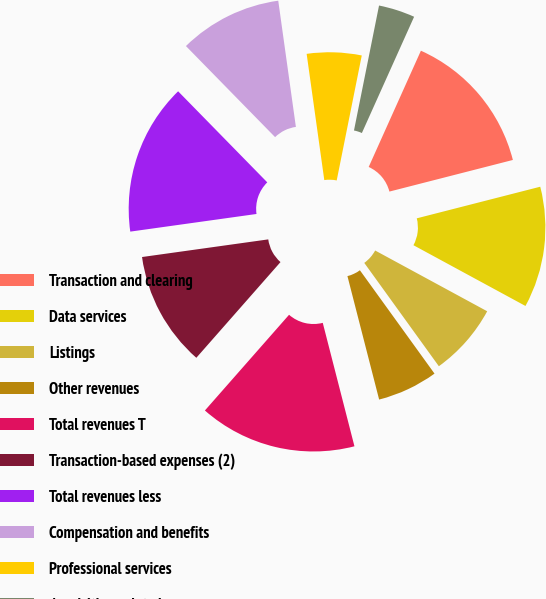Convert chart to OTSL. <chart><loc_0><loc_0><loc_500><loc_500><pie_chart><fcel>Transaction and clearing<fcel>Data services<fcel>Listings<fcel>Other revenues<fcel>Total revenues T<fcel>Transaction-based expenses (2)<fcel>Total revenues less<fcel>Compensation and benefits<fcel>Professional services<fcel>Acquisition-related<nl><fcel>14.29%<fcel>11.9%<fcel>7.14%<fcel>5.95%<fcel>15.48%<fcel>11.31%<fcel>14.88%<fcel>10.12%<fcel>5.36%<fcel>3.57%<nl></chart> 